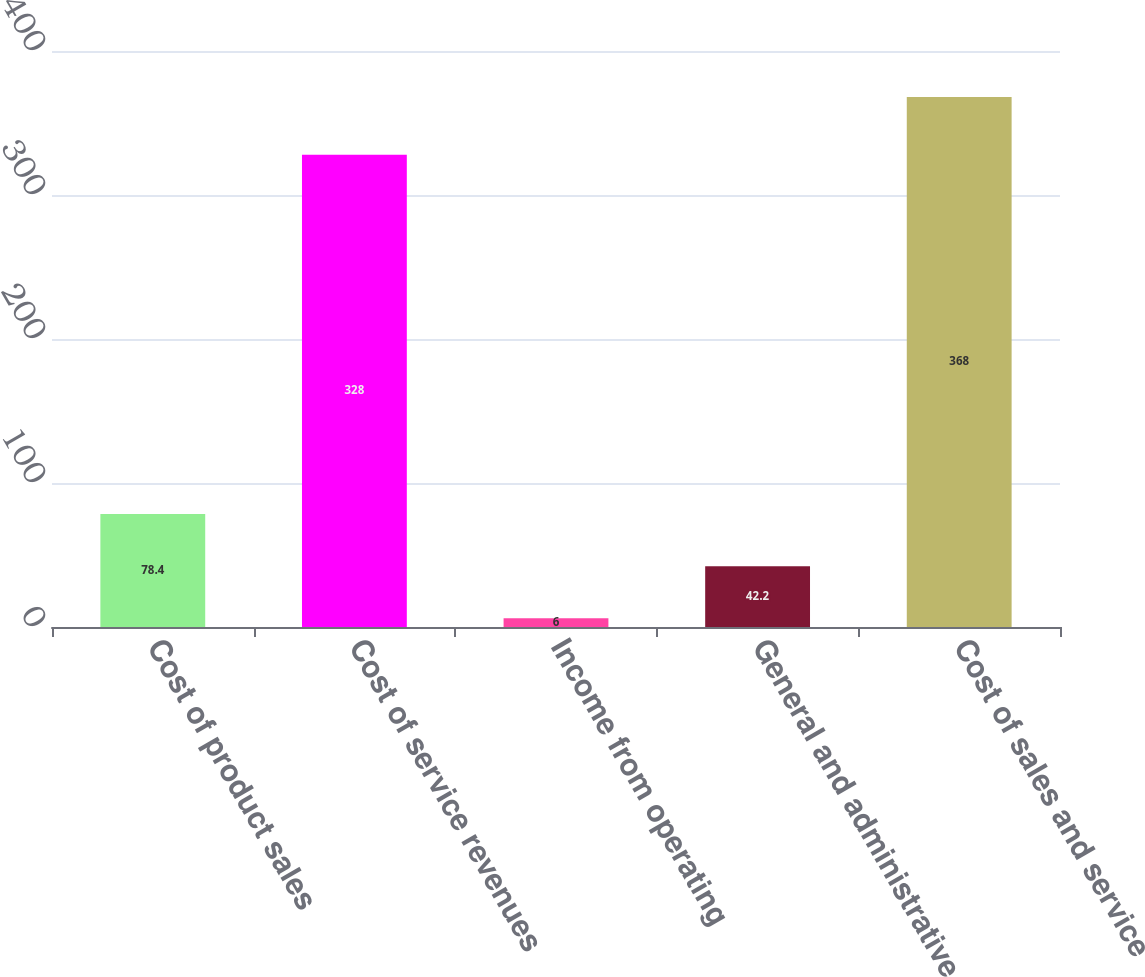Convert chart to OTSL. <chart><loc_0><loc_0><loc_500><loc_500><bar_chart><fcel>Cost of product sales<fcel>Cost of service revenues<fcel>Income from operating<fcel>General and administrative<fcel>Cost of sales and service<nl><fcel>78.4<fcel>328<fcel>6<fcel>42.2<fcel>368<nl></chart> 